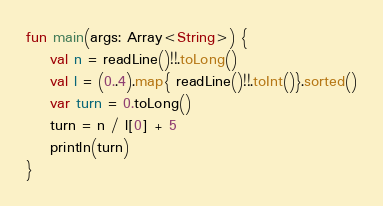Convert code to text. <code><loc_0><loc_0><loc_500><loc_500><_Kotlin_>fun main(args: Array<String>) {
    val n = readLine()!!.toLong()
    val l = (0..4).map{ readLine()!!.toInt()}.sorted()
    var turn = 0.toLong()
    turn = n / l[0] + 5
    println(turn)
}</code> 